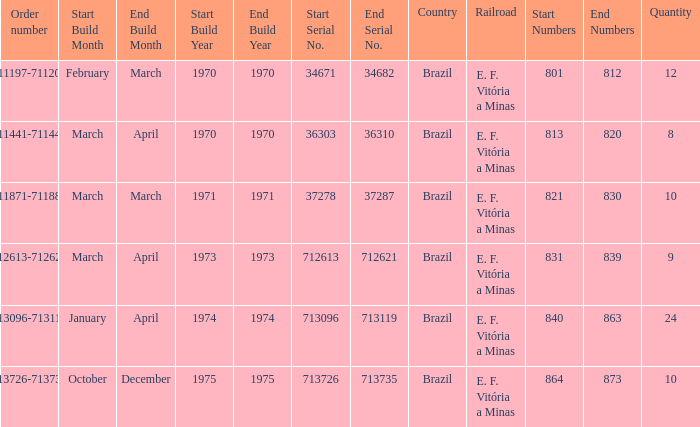The numbers 801-812 are in which country? Brazil. 